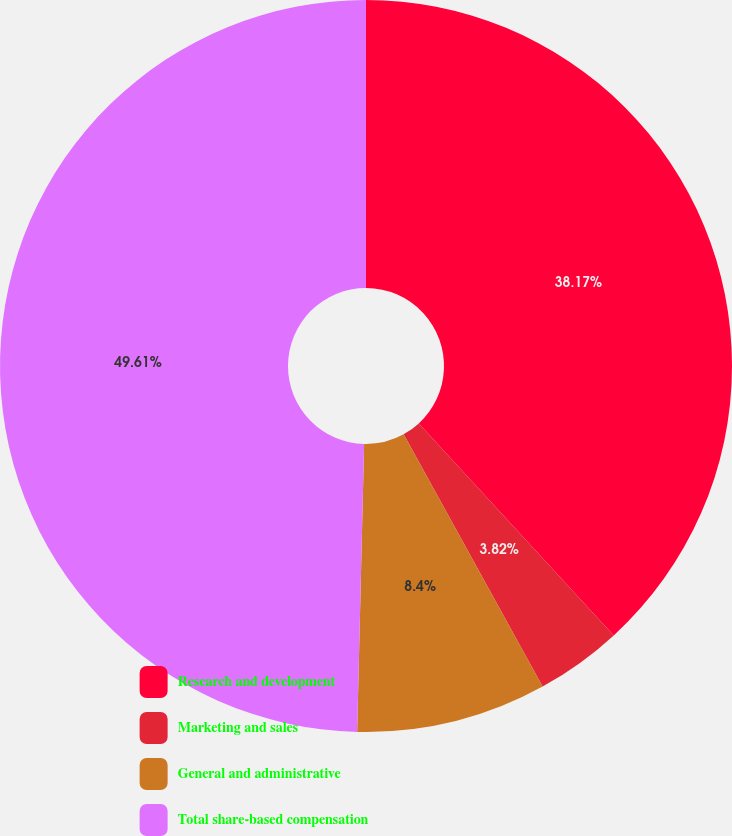Convert chart to OTSL. <chart><loc_0><loc_0><loc_500><loc_500><pie_chart><fcel>Research and development<fcel>Marketing and sales<fcel>General and administrative<fcel>Total share-based compensation<nl><fcel>38.17%<fcel>3.82%<fcel>8.4%<fcel>49.62%<nl></chart> 